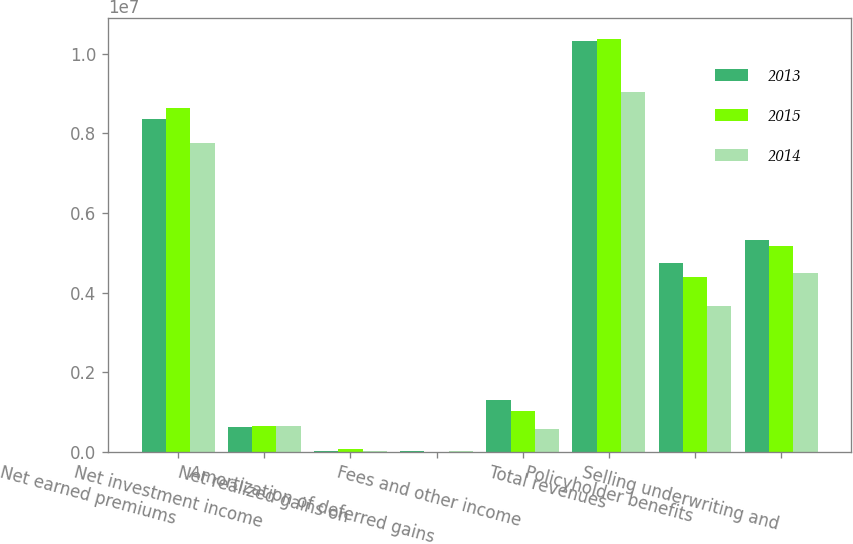Convert chart to OTSL. <chart><loc_0><loc_0><loc_500><loc_500><stacked_bar_chart><ecel><fcel>Net earned premiums<fcel>Net investment income<fcel>Net realized gains on<fcel>Amortization of deferred gains<fcel>Fees and other income<fcel>Total revenues<fcel>Policyholder benefits<fcel>Selling underwriting and<nl><fcel>2013<fcel>8.351e+06<fcel>626217<fcel>31826<fcel>12988<fcel>1.30347e+06<fcel>1.03255e+07<fcel>4.74254e+06<fcel>5.32666e+06<nl><fcel>2015<fcel>8.63214e+06<fcel>656429<fcel>60783<fcel>1506<fcel>1.0338e+06<fcel>1.03817e+07<fcel>4.40533e+06<fcel>5.17379e+06<nl><fcel>2014<fcel>7.7598e+06<fcel>650296<fcel>34525<fcel>16310<fcel>586730<fcel>9.04766e+06<fcel>3.67553e+06<fcel>4.50469e+06<nl></chart> 